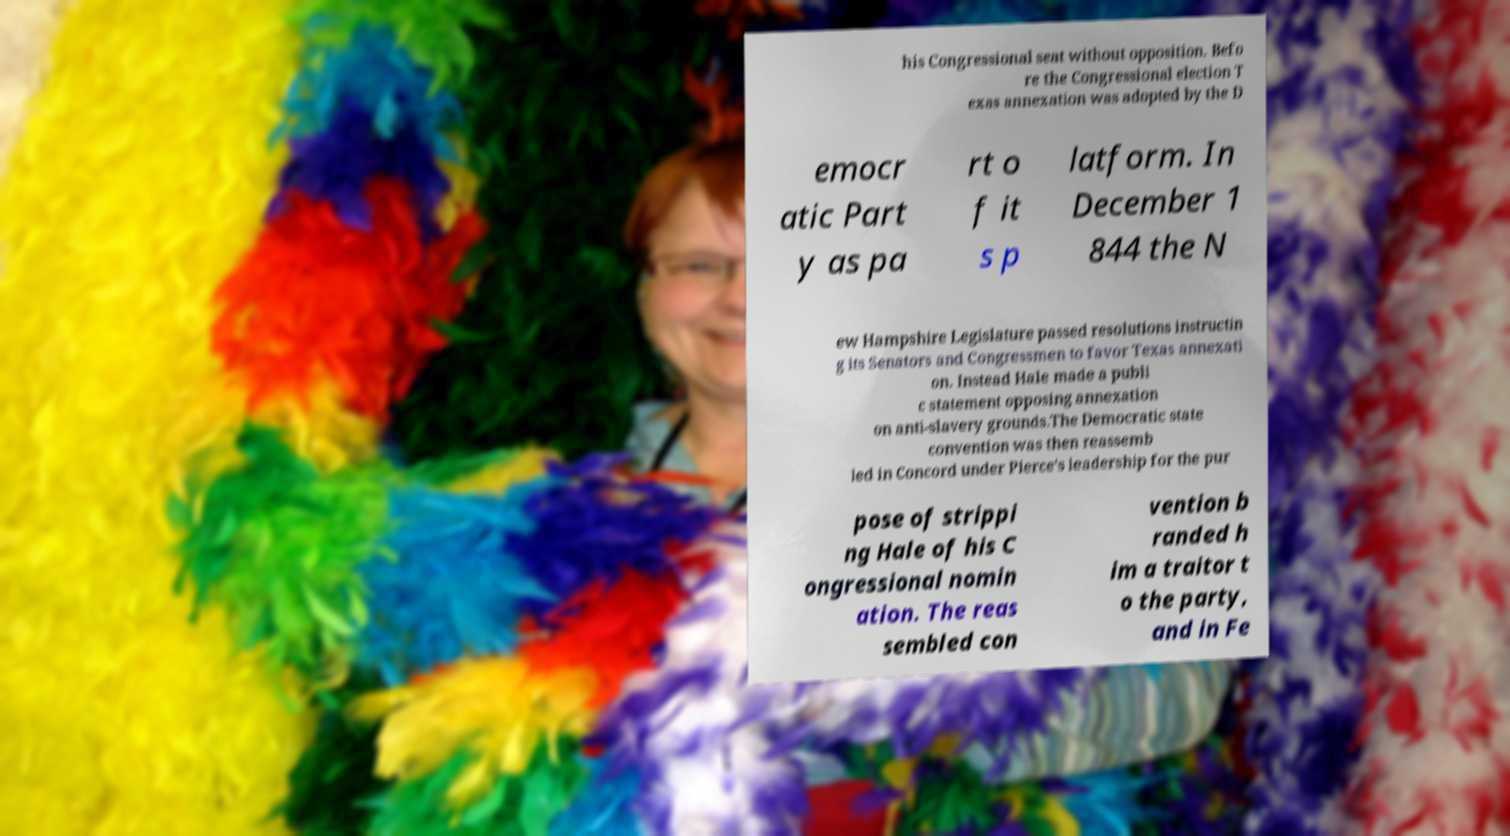Please read and relay the text visible in this image. What does it say? his Congressional seat without opposition. Befo re the Congressional election T exas annexation was adopted by the D emocr atic Part y as pa rt o f it s p latform. In December 1 844 the N ew Hampshire Legislature passed resolutions instructin g its Senators and Congressmen to favor Texas annexati on. Instead Hale made a publi c statement opposing annexation on anti-slavery grounds.The Democratic state convention was then reassemb led in Concord under Pierce's leadership for the pur pose of strippi ng Hale of his C ongressional nomin ation. The reas sembled con vention b randed h im a traitor t o the party, and in Fe 